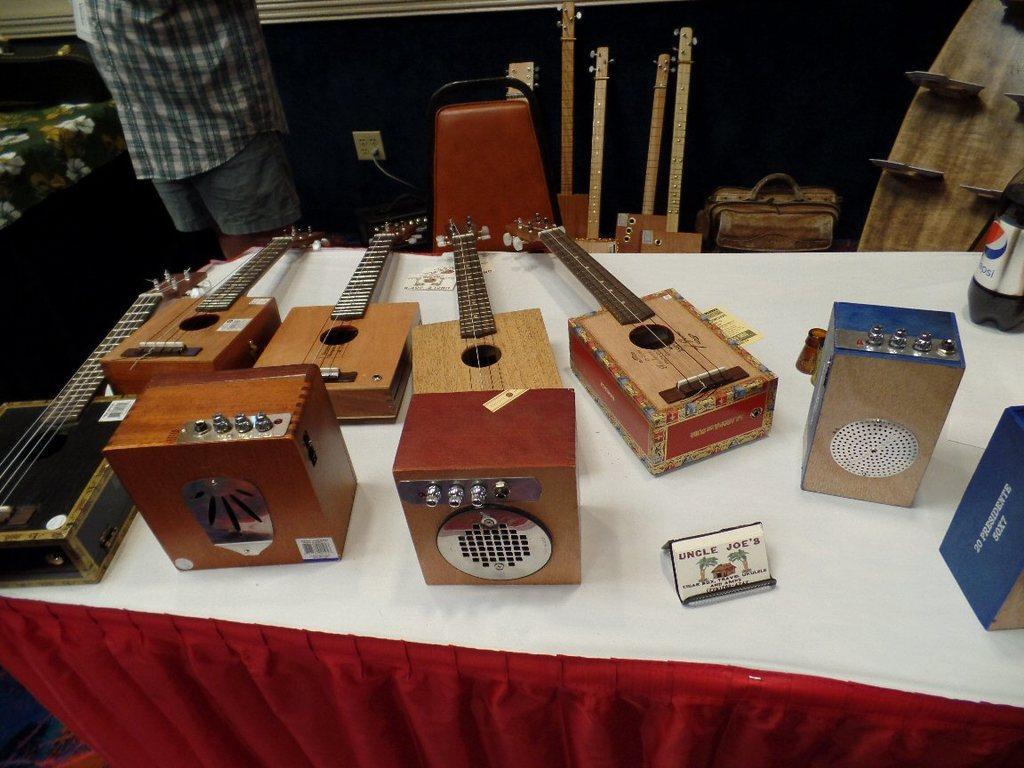Please provide a concise description of this image. As we can see in the image there is a man chair and few musical instruments. 